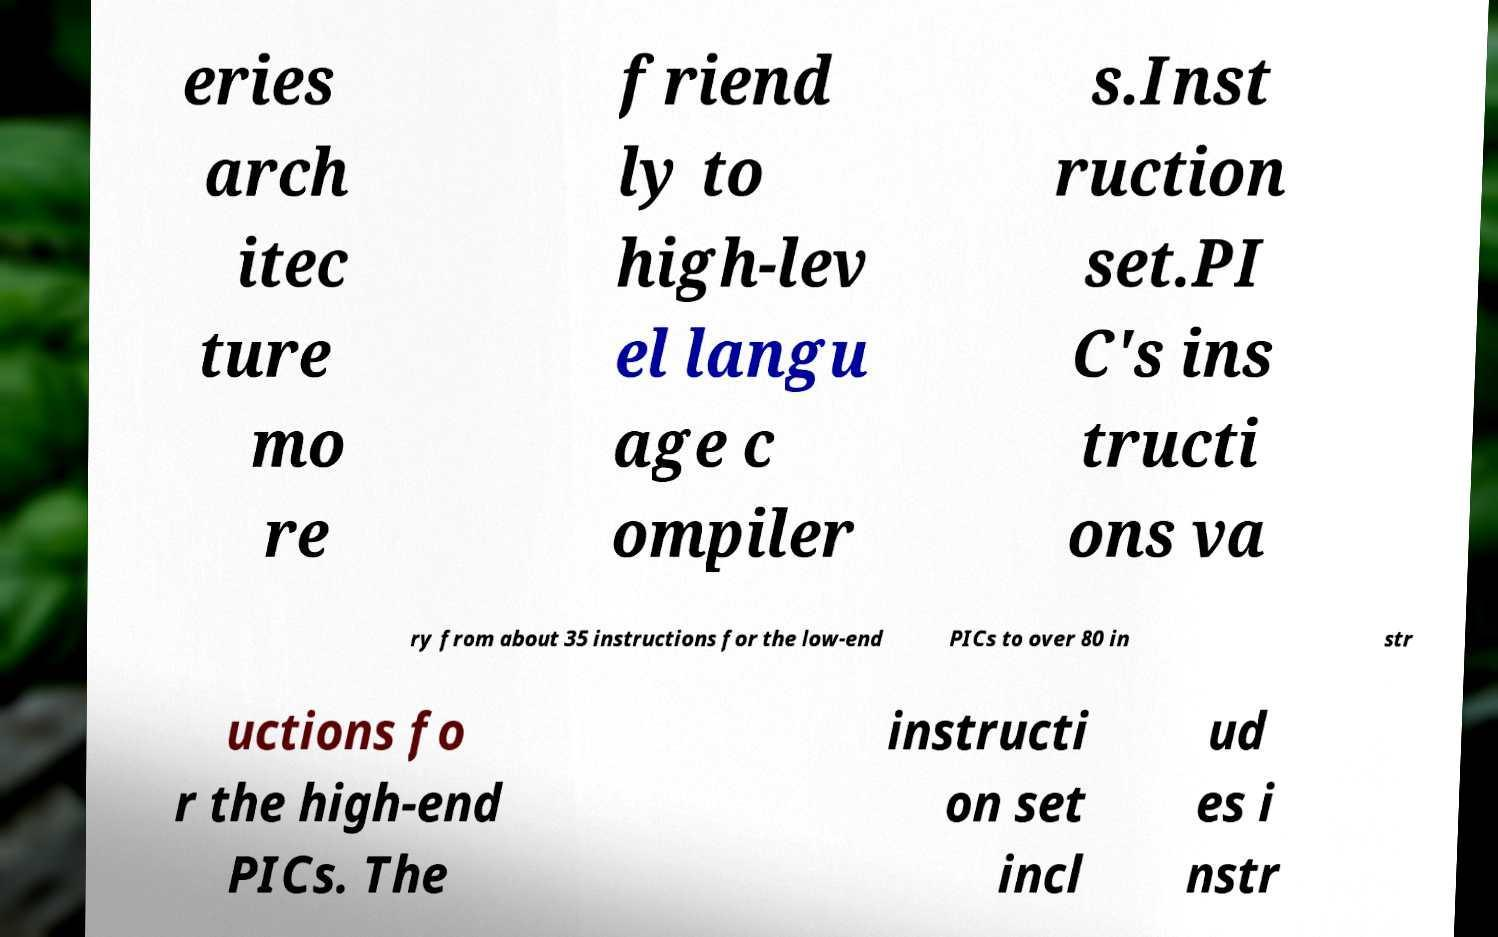Can you read and provide the text displayed in the image?This photo seems to have some interesting text. Can you extract and type it out for me? eries arch itec ture mo re friend ly to high-lev el langu age c ompiler s.Inst ruction set.PI C's ins tructi ons va ry from about 35 instructions for the low-end PICs to over 80 in str uctions fo r the high-end PICs. The instructi on set incl ud es i nstr 